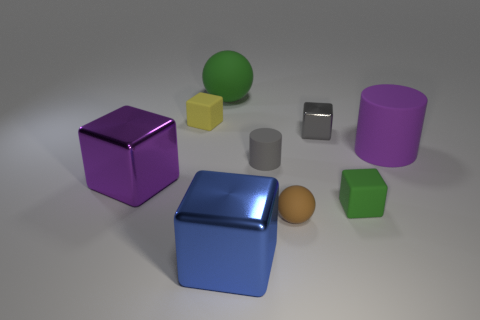Subtract all tiny gray cubes. How many cubes are left? 4 Subtract all gray cylinders. How many cylinders are left? 1 Subtract 2 balls. How many balls are left? 0 Subtract all cylinders. How many objects are left? 7 Subtract all big purple things. Subtract all tiny metal cubes. How many objects are left? 6 Add 4 green spheres. How many green spheres are left? 5 Add 1 tiny yellow cubes. How many tiny yellow cubes exist? 2 Subtract 0 cyan blocks. How many objects are left? 9 Subtract all cyan cubes. Subtract all blue cylinders. How many cubes are left? 5 Subtract all green blocks. How many green spheres are left? 1 